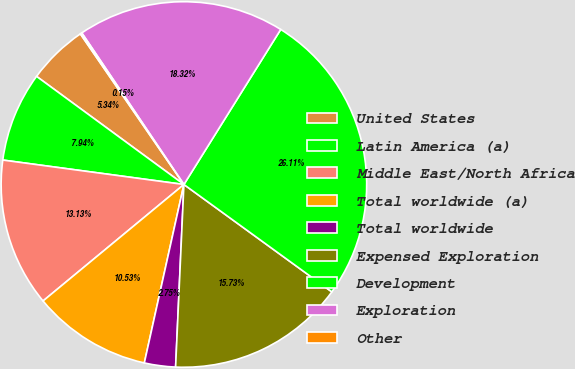Convert chart. <chart><loc_0><loc_0><loc_500><loc_500><pie_chart><fcel>United States<fcel>Latin America (a)<fcel>Middle East/North Africa<fcel>Total worldwide (a)<fcel>Total worldwide<fcel>Expensed Exploration<fcel>Development<fcel>Exploration<fcel>Other<nl><fcel>5.34%<fcel>7.94%<fcel>13.13%<fcel>10.53%<fcel>2.75%<fcel>15.73%<fcel>26.11%<fcel>18.32%<fcel>0.15%<nl></chart> 